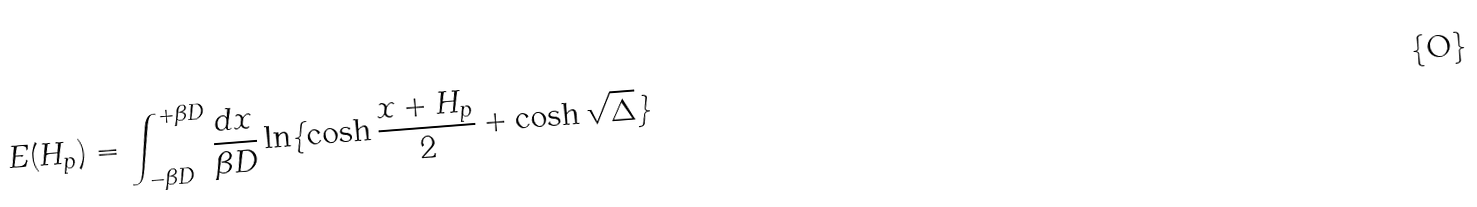Convert formula to latex. <formula><loc_0><loc_0><loc_500><loc_500>E ( H _ { p } ) = \int ^ { + \beta D } _ { - \beta D } \frac { d x } { \beta D } \ln \{ \cosh \frac { x + H _ { p } } { 2 } + \cosh \sqrt { \Delta } \}</formula> 